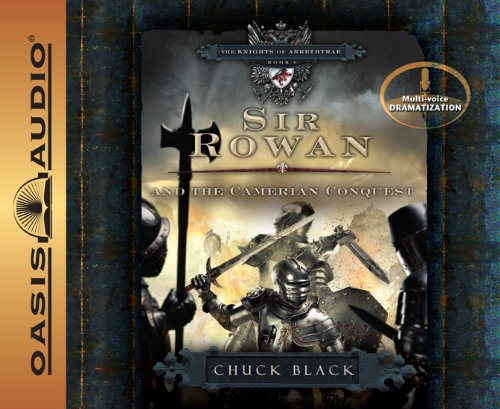What is the title of this book? The full title of the book as shown in the image is 'Sir Rowan and the Camerian Conquest (The Knights of Arrethtrae)', which suggests a narrative set in a medieval or fantasy setting focused on the character Sir Rowan. 